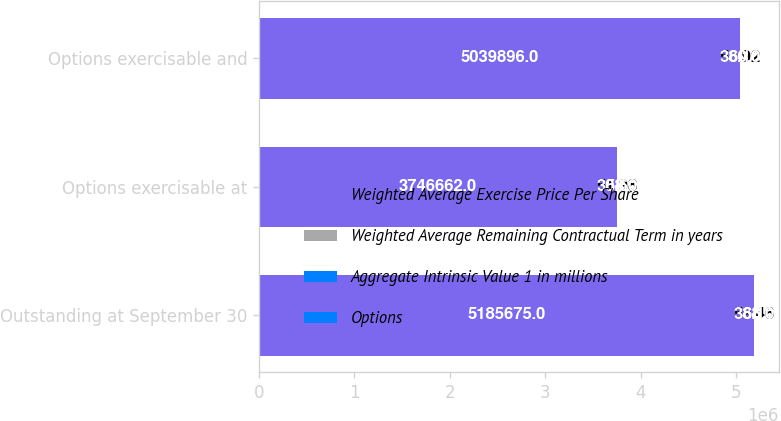<chart> <loc_0><loc_0><loc_500><loc_500><stacked_bar_chart><ecel><fcel>Outstanding at September 30<fcel>Options exercisable at<fcel>Options exercisable and<nl><fcel>Weighted Average Exercise Price Per Share<fcel>5.18568e+06<fcel>3.74666e+06<fcel>5.0399e+06<nl><fcel>Weighted Average Remaining Contractual Term in years<fcel>59.46<fcel>51.98<fcel>58.92<nl><fcel>Aggregate Intrinsic Value 1 in millions<fcel>6.1<fcel>5.6<fcel>6.1<nl><fcel>Options<fcel>388<fcel>308<fcel>380<nl></chart> 